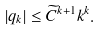<formula> <loc_0><loc_0><loc_500><loc_500>| q _ { k } | \leq \widetilde { C } ^ { k + 1 } k ^ { k } .</formula> 